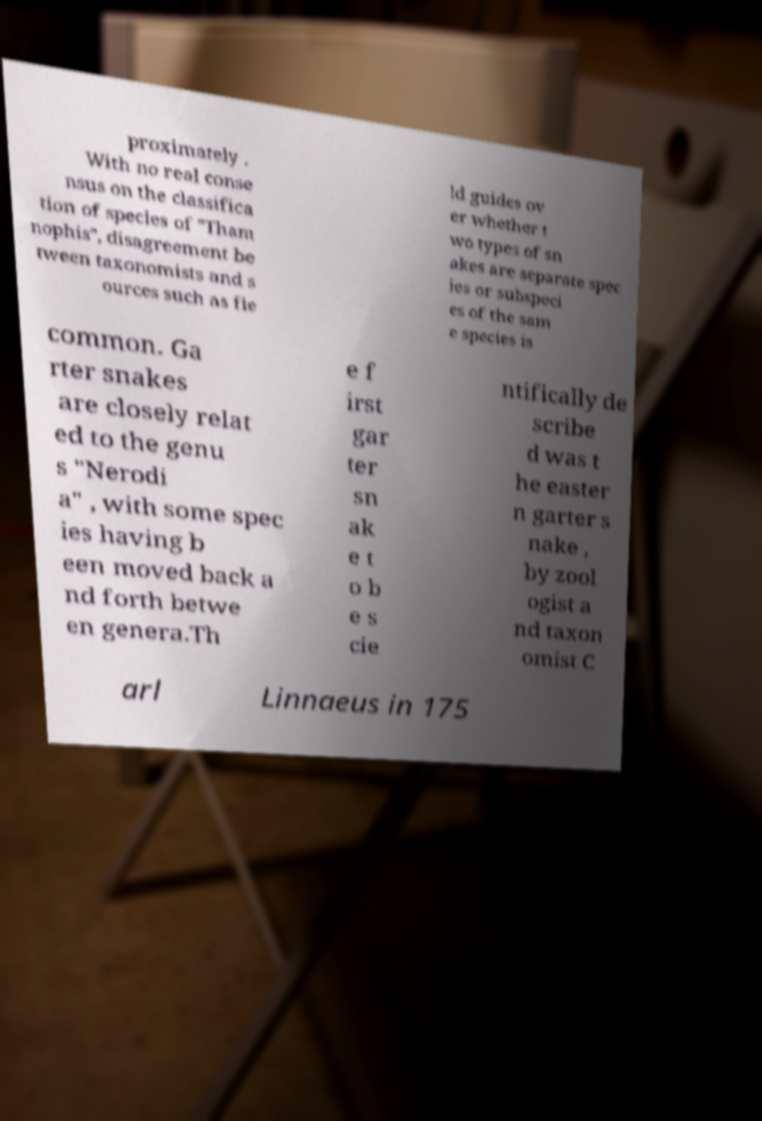Could you assist in decoding the text presented in this image and type it out clearly? proximately . With no real conse nsus on the classifica tion of species of "Tham nophis", disagreement be tween taxonomists and s ources such as fie ld guides ov er whether t wo types of sn akes are separate spec ies or subspeci es of the sam e species is common. Ga rter snakes are closely relat ed to the genu s "Nerodi a" , with some spec ies having b een moved back a nd forth betwe en genera.Th e f irst gar ter sn ak e t o b e s cie ntifically de scribe d was t he easter n garter s nake , by zool ogist a nd taxon omist C arl Linnaeus in 175 